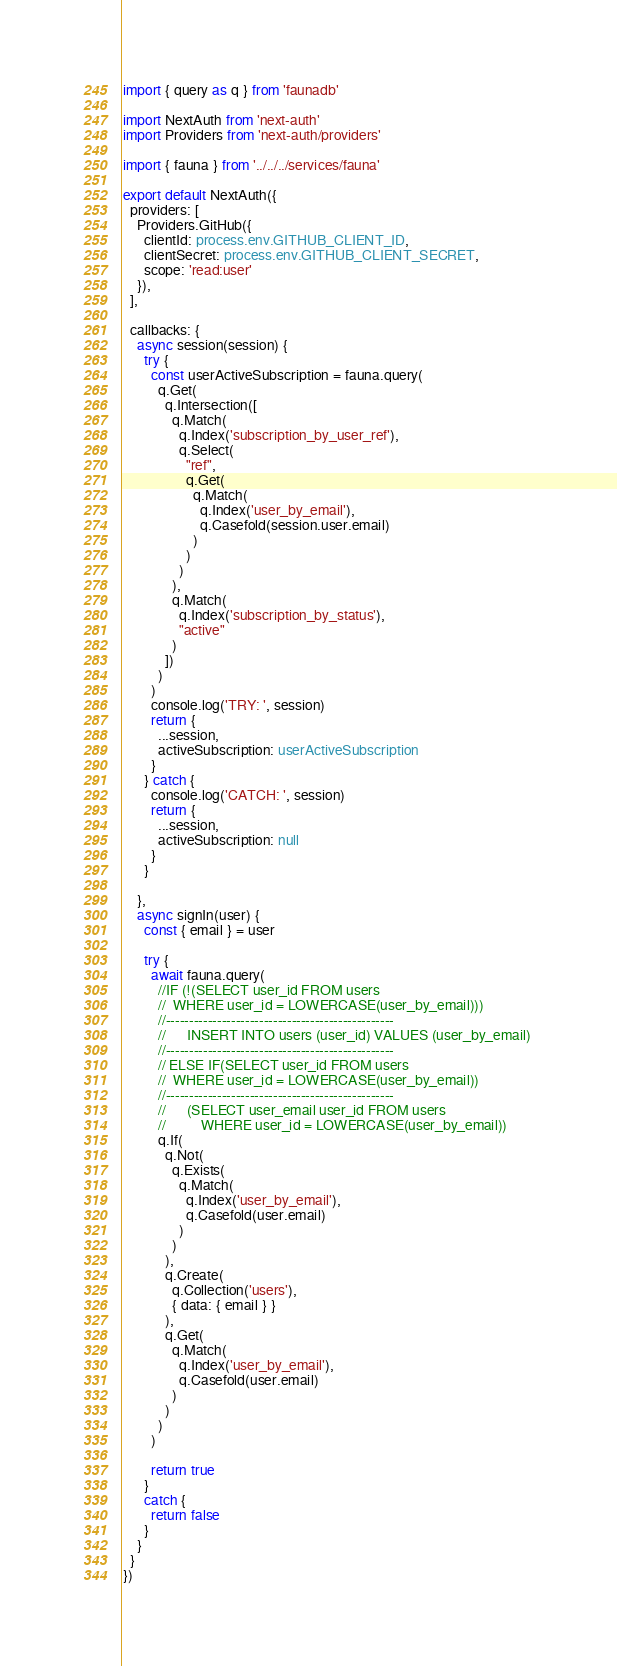Convert code to text. <code><loc_0><loc_0><loc_500><loc_500><_TypeScript_>import { query as q } from 'faunadb'

import NextAuth from 'next-auth'
import Providers from 'next-auth/providers'

import { fauna } from '../../../services/fauna'

export default NextAuth({
  providers: [
    Providers.GitHub({
      clientId: process.env.GITHUB_CLIENT_ID,
      clientSecret: process.env.GITHUB_CLIENT_SECRET,
      scope: 'read:user'
    }),
  ],

  callbacks: {
    async session(session) {
      try {
        const userActiveSubscription = fauna.query(
          q.Get(
            q.Intersection([
              q.Match(
                q.Index('subscription_by_user_ref'),
                q.Select(
                  "ref",
                  q.Get(
                    q.Match(
                      q.Index('user_by_email'),
                      q.Casefold(session.user.email)
                    )
                  )
                )
              ),
              q.Match(
                q.Index('subscription_by_status'),
                "active"
              )
            ])
          )
        )
        console.log('TRY: ', session)
        return {
          ...session,
          activeSubscription: userActiveSubscription
        }
      } catch {
        console.log('CATCH: ', session)
        return {
          ...session,
          activeSubscription: null
        }
      }

    },
    async signIn(user) {
      const { email } = user

      try {
        await fauna.query(
          //IF (!(SELECT user_id FROM users 
          //  WHERE user_id = LOWERCASE(user_by_email)))
          //-------------------------------------------------
          //      INSERT INTO users (user_id) VALUES (user_by_email) 
          //-------------------------------------------------
          // ELSE IF(SELECT user_id FROM users 
          //  WHERE user_id = LOWERCASE(user_by_email))
          //-------------------------------------------------
          //      (SELECT user_email user_id FROM users 
          //          WHERE user_id = LOWERCASE(user_by_email))
          q.If(
            q.Not(
              q.Exists(
                q.Match(
                  q.Index('user_by_email'),
                  q.Casefold(user.email)
                )
              )
            ),
            q.Create(
              q.Collection('users'),
              { data: { email } }
            ),
            q.Get(
              q.Match(
                q.Index('user_by_email'),
                q.Casefold(user.email)
              )
            )
          )
        )

        return true
      }
      catch {
        return false
      }
    }
  }
})</code> 